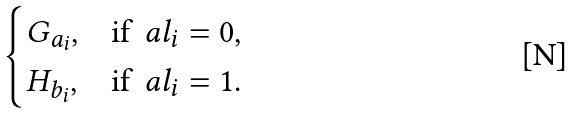<formula> <loc_0><loc_0><loc_500><loc_500>\begin{cases} G _ { a _ { i } } , & \text {if} \, \ a l _ { i } = 0 , \\ H _ { b _ { i } } , & \text {if} \, \ a l _ { i } = 1 . \\ \end{cases}</formula> 